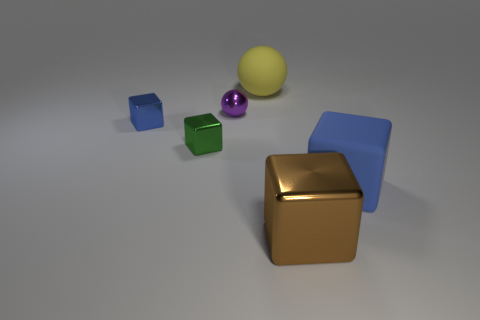Can you describe the arrangement of shapes in relation to the purple sphere? Positioned centrally at the back is the purple sphere. To its left, there is a green cube, and a gold cube sits prominently to its right. In the foreground, there's a blue cube to the left and a yellow sphere to the right, forming a rough semicircle around the purple sphere. 